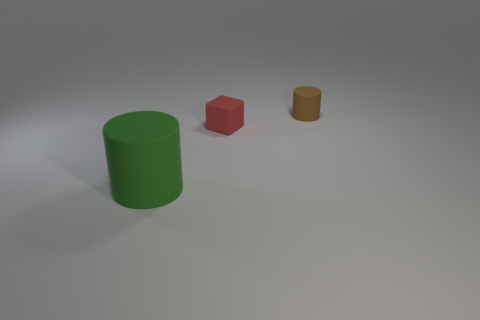Add 3 big gray metallic cylinders. How many objects exist? 6 Subtract all cylinders. How many objects are left? 1 Subtract all small brown rubber things. Subtract all matte blocks. How many objects are left? 1 Add 3 matte cubes. How many matte cubes are left? 4 Add 3 cyan rubber blocks. How many cyan rubber blocks exist? 3 Subtract 0 brown spheres. How many objects are left? 3 